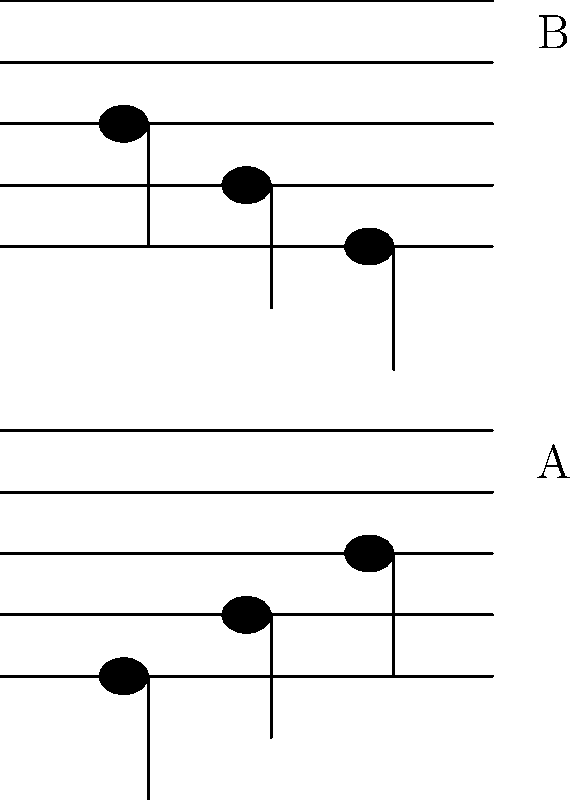As a musician familiar with musical notation, analyze the spatial relationship between the notes in staff A and staff B. If the notes in staff A were to be flipped vertically, which staff would they most closely resemble? To solve this puzzle, we need to follow these steps:

1. Observe the pattern of notes in staff A:
   - The first note is on the bottom line
   - The second note is on the space above the bottom line
   - The third note is on the second line from the bottom

2. Observe the pattern of notes in staff B:
   - The first note is on the space below the top line
   - The second note is on the second line from the top
   - The third note is on the top line

3. Imagine flipping staff A vertically:
   - The bottom line would become the top line
   - The space above the bottom line would become the space below the top line
   - The second line from the bottom would become the second line from the top

4. Compare the flipped pattern of staff A with staff B:
   - The first note would be on the space below the top line (matches B)
   - The second note would be on the second line from the top (matches B)
   - The third note would be on the top line (matches B)

5. Conclusion: The flipped version of staff A would exactly match the pattern in staff B.

This spatial relationship demonstrates the concept of inversion in music, where a melody can be turned upside down while maintaining its rhythmic structure.
Answer: Staff B 